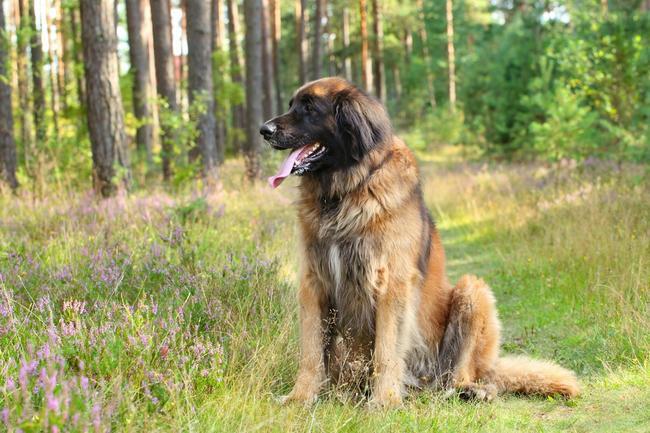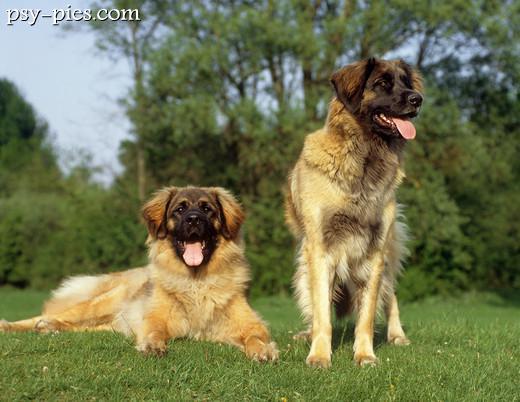The first image is the image on the left, the second image is the image on the right. Examine the images to the left and right. Is the description "There are two dogs in one of the images." accurate? Answer yes or no. Yes. 